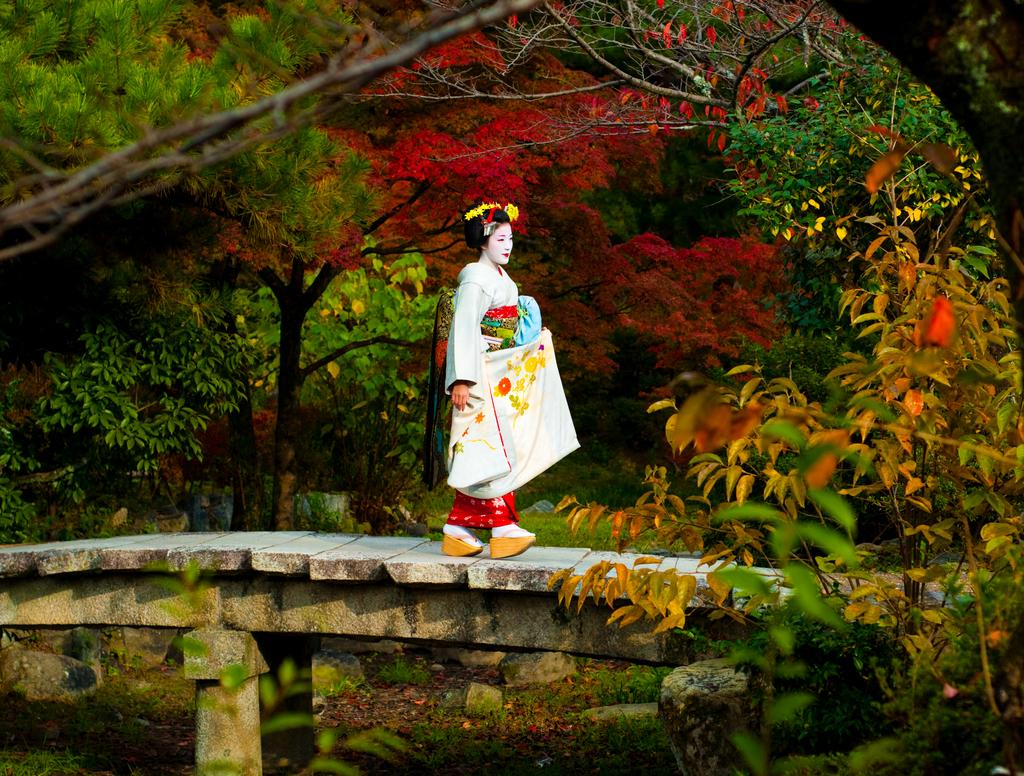Who is present in the image? There is a woman in the image. What is the woman doing in the image? The woman is walking on a wooden walkway. What can be seen in the background of the image? There are trees in the background of the image. What type of quill is the woman using to write a dinner invitation in the image? There is no quill or dinner invitation present in the image; the woman is simply walking on a wooden walkway. 